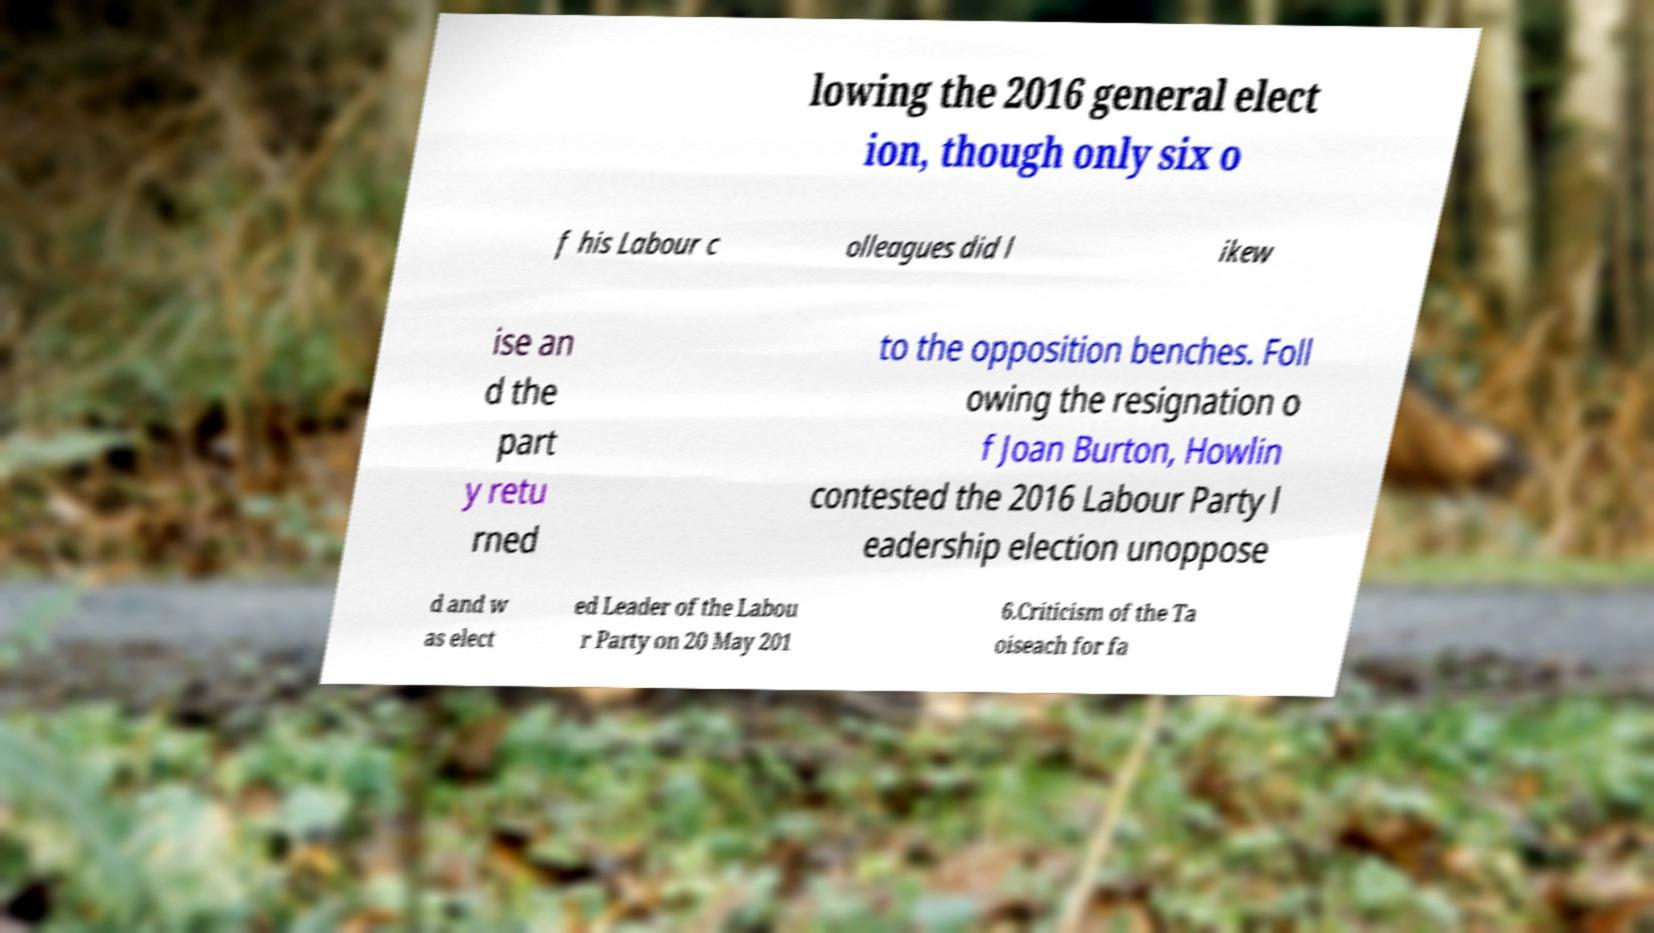Can you read and provide the text displayed in the image?This photo seems to have some interesting text. Can you extract and type it out for me? lowing the 2016 general elect ion, though only six o f his Labour c olleagues did l ikew ise an d the part y retu rned to the opposition benches. Foll owing the resignation o f Joan Burton, Howlin contested the 2016 Labour Party l eadership election unoppose d and w as elect ed Leader of the Labou r Party on 20 May 201 6.Criticism of the Ta oiseach for fa 